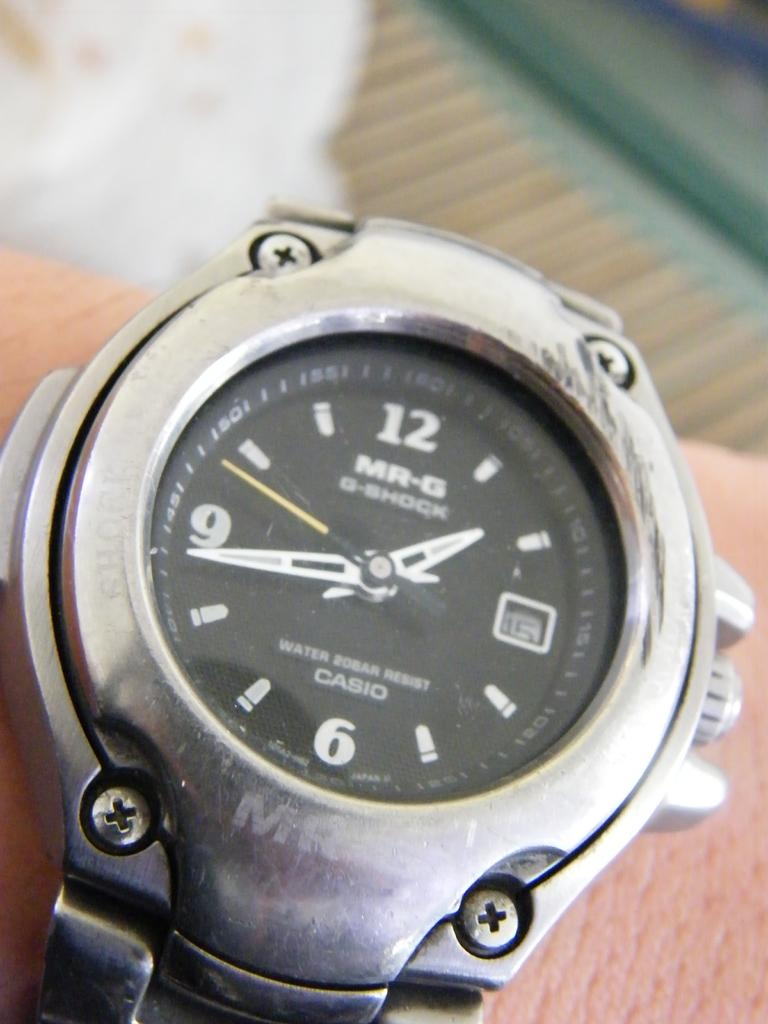<image>
Summarize the visual content of the image. A man is wearing a silver G-shock wrist watch. 